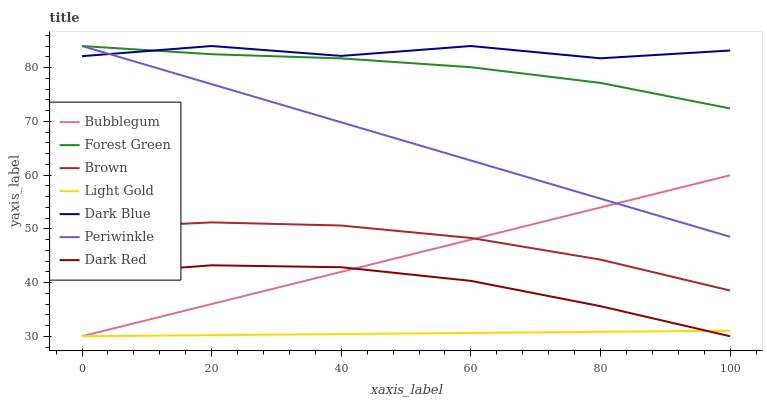Does Light Gold have the minimum area under the curve?
Answer yes or no. Yes. Does Dark Blue have the maximum area under the curve?
Answer yes or no. Yes. Does Dark Red have the minimum area under the curve?
Answer yes or no. No. Does Dark Red have the maximum area under the curve?
Answer yes or no. No. Is Light Gold the smoothest?
Answer yes or no. Yes. Is Dark Blue the roughest?
Answer yes or no. Yes. Is Dark Red the smoothest?
Answer yes or no. No. Is Dark Red the roughest?
Answer yes or no. No. Does Dark Red have the lowest value?
Answer yes or no. Yes. Does Dark Blue have the lowest value?
Answer yes or no. No. Does Periwinkle have the highest value?
Answer yes or no. Yes. Does Dark Red have the highest value?
Answer yes or no. No. Is Brown less than Forest Green?
Answer yes or no. Yes. Is Dark Blue greater than Light Gold?
Answer yes or no. Yes. Does Dark Red intersect Bubblegum?
Answer yes or no. Yes. Is Dark Red less than Bubblegum?
Answer yes or no. No. Is Dark Red greater than Bubblegum?
Answer yes or no. No. Does Brown intersect Forest Green?
Answer yes or no. No. 